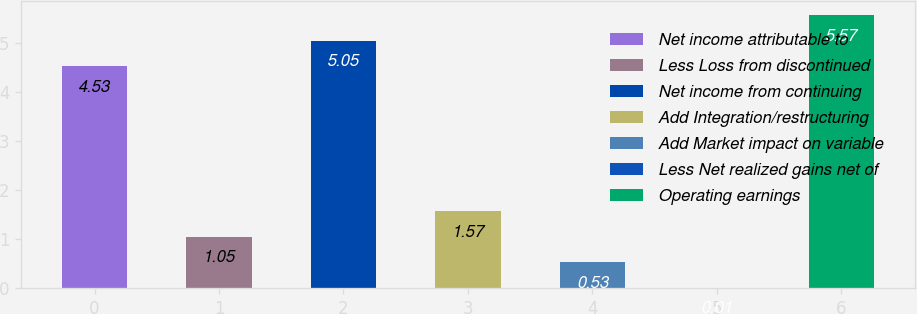<chart> <loc_0><loc_0><loc_500><loc_500><bar_chart><fcel>Net income attributable to<fcel>Less Loss from discontinued<fcel>Net income from continuing<fcel>Add Integration/restructuring<fcel>Add Market impact on variable<fcel>Less Net realized gains net of<fcel>Operating earnings<nl><fcel>4.53<fcel>1.05<fcel>5.05<fcel>1.57<fcel>0.53<fcel>0.01<fcel>5.57<nl></chart> 